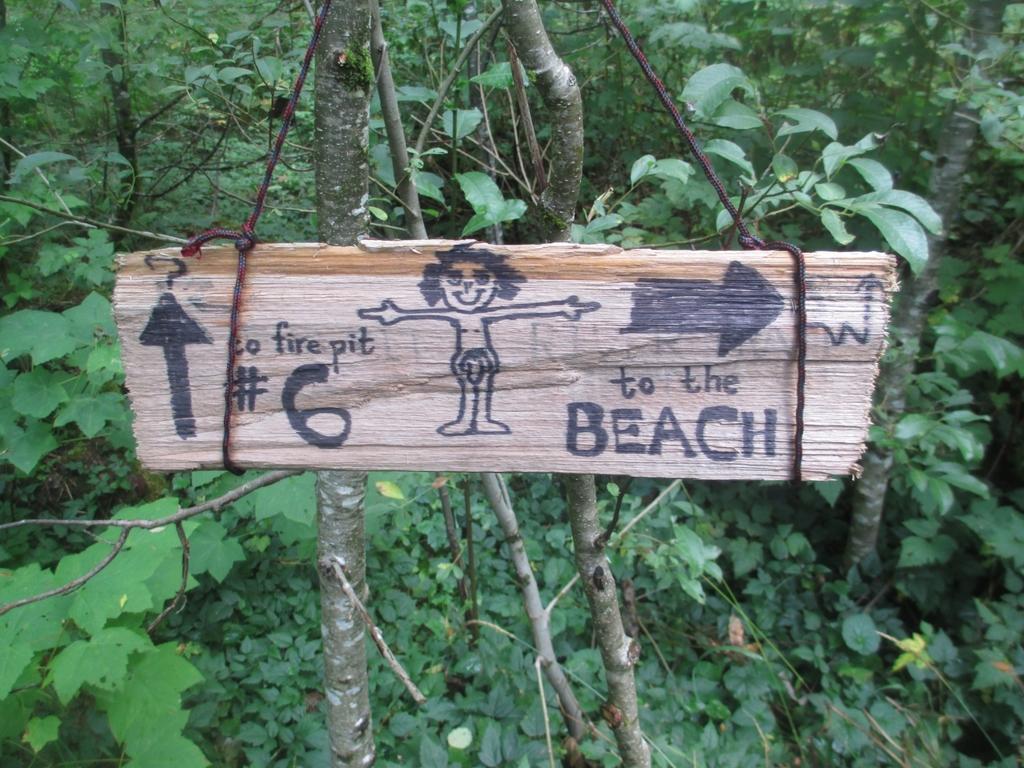Could you give a brief overview of what you see in this image? In the image we can see there is a wooden plank on which drawings are done and it is hanged on the tree. Behind there are lot of trees. 